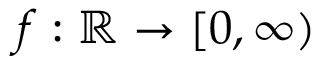<formula> <loc_0><loc_0><loc_500><loc_500>f \colon \mathbb { R } \rightarrow [ 0 , \infty )</formula> 